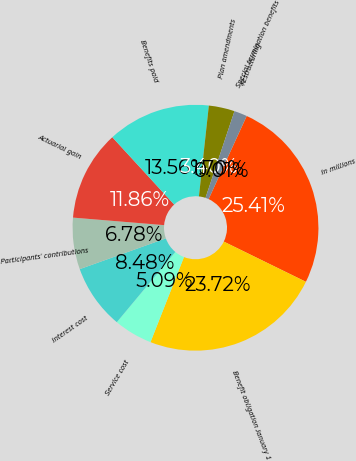<chart> <loc_0><loc_0><loc_500><loc_500><pie_chart><fcel>In millions<fcel>Benefit obligation January 1<fcel>Service cost<fcel>Interest cost<fcel>Participants' contributions<fcel>Actuarial gain<fcel>Benefits paid<fcel>Plan amendments<fcel>Restructuring<fcel>Special termination benefits<nl><fcel>25.41%<fcel>23.72%<fcel>5.09%<fcel>8.48%<fcel>6.78%<fcel>11.86%<fcel>13.56%<fcel>3.4%<fcel>1.7%<fcel>0.01%<nl></chart> 